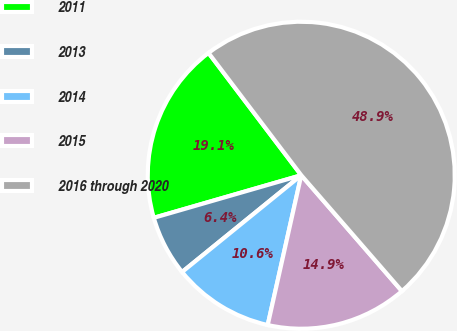Convert chart to OTSL. <chart><loc_0><loc_0><loc_500><loc_500><pie_chart><fcel>2011<fcel>2013<fcel>2014<fcel>2015<fcel>2016 through 2020<nl><fcel>19.15%<fcel>6.38%<fcel>10.64%<fcel>14.89%<fcel>48.94%<nl></chart> 